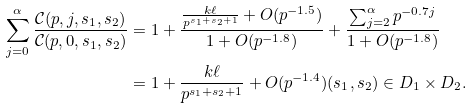<formula> <loc_0><loc_0><loc_500><loc_500>\sum _ { j = 0 } ^ { \alpha } \frac { \mathcal { C } ( p , j , s _ { 1 } , s _ { 2 } ) } { \mathcal { C } ( p , 0 , s _ { 1 } , s _ { 2 } ) } & = 1 + \frac { \frac { k \ell } { p ^ { s _ { 1 } + s _ { 2 } + 1 } } + O ( p ^ { - 1 . 5 } ) } { 1 + O ( p ^ { - 1 . 8 } ) } + \frac { \sum _ { j = 2 } ^ { \alpha } p ^ { - 0 . 7 j } } { 1 + O ( p ^ { - 1 . 8 } ) } \\ & = 1 + \frac { k \ell } { p ^ { s _ { 1 } + s _ { 2 } + 1 } } + O ( p ^ { - 1 . 4 } ) ( s _ { 1 } , s _ { 2 } ) \in D _ { 1 } \times D _ { 2 } .</formula> 